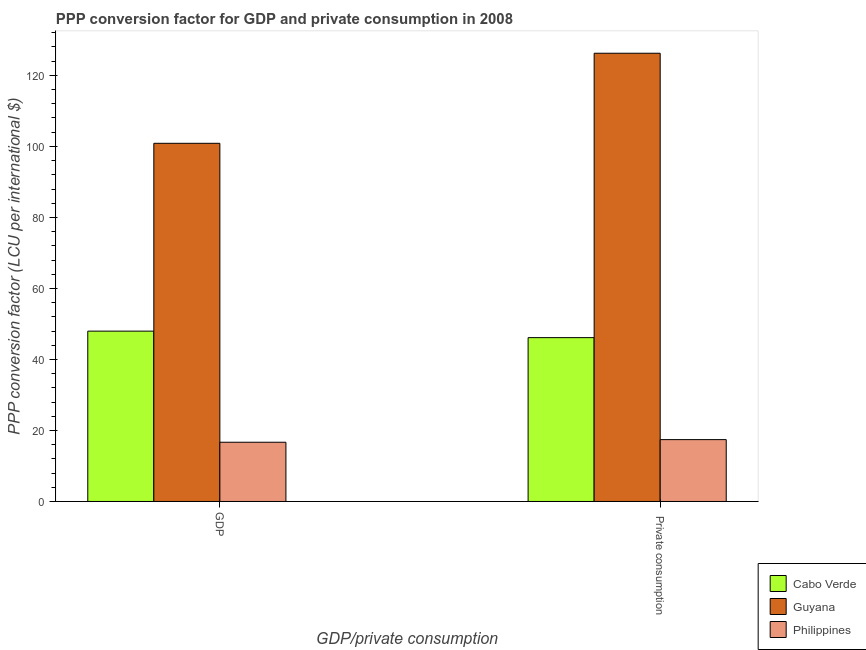How many groups of bars are there?
Offer a very short reply. 2. Are the number of bars on each tick of the X-axis equal?
Your answer should be compact. Yes. How many bars are there on the 1st tick from the right?
Your answer should be compact. 3. What is the label of the 1st group of bars from the left?
Your response must be concise. GDP. What is the ppp conversion factor for gdp in Guyana?
Your response must be concise. 100.87. Across all countries, what is the maximum ppp conversion factor for gdp?
Give a very brief answer. 100.87. Across all countries, what is the minimum ppp conversion factor for private consumption?
Make the answer very short. 17.42. In which country was the ppp conversion factor for private consumption maximum?
Provide a succinct answer. Guyana. What is the total ppp conversion factor for private consumption in the graph?
Your answer should be very brief. 189.8. What is the difference between the ppp conversion factor for gdp in Cabo Verde and that in Guyana?
Ensure brevity in your answer.  -52.9. What is the difference between the ppp conversion factor for gdp in Cabo Verde and the ppp conversion factor for private consumption in Philippines?
Ensure brevity in your answer.  30.55. What is the average ppp conversion factor for private consumption per country?
Give a very brief answer. 63.27. What is the difference between the ppp conversion factor for gdp and ppp conversion factor for private consumption in Guyana?
Provide a succinct answer. -25.36. In how many countries, is the ppp conversion factor for private consumption greater than 24 LCU?
Your response must be concise. 2. What is the ratio of the ppp conversion factor for private consumption in Guyana to that in Cabo Verde?
Offer a terse response. 2.74. Is the ppp conversion factor for gdp in Philippines less than that in Cabo Verde?
Give a very brief answer. Yes. What does the 2nd bar from the left in  Private consumption represents?
Your response must be concise. Guyana. Are all the bars in the graph horizontal?
Your answer should be very brief. No. How many countries are there in the graph?
Provide a succinct answer. 3. What is the difference between two consecutive major ticks on the Y-axis?
Ensure brevity in your answer.  20. Where does the legend appear in the graph?
Give a very brief answer. Bottom right. What is the title of the graph?
Your answer should be compact. PPP conversion factor for GDP and private consumption in 2008. Does "Uganda" appear as one of the legend labels in the graph?
Provide a succinct answer. No. What is the label or title of the X-axis?
Make the answer very short. GDP/private consumption. What is the label or title of the Y-axis?
Ensure brevity in your answer.  PPP conversion factor (LCU per international $). What is the PPP conversion factor (LCU per international $) in Cabo Verde in GDP?
Provide a succinct answer. 47.97. What is the PPP conversion factor (LCU per international $) in Guyana in GDP?
Ensure brevity in your answer.  100.87. What is the PPP conversion factor (LCU per international $) of Philippines in GDP?
Offer a terse response. 16.68. What is the PPP conversion factor (LCU per international $) in Cabo Verde in  Private consumption?
Keep it short and to the point. 46.14. What is the PPP conversion factor (LCU per international $) of Guyana in  Private consumption?
Provide a short and direct response. 126.24. What is the PPP conversion factor (LCU per international $) of Philippines in  Private consumption?
Your response must be concise. 17.42. Across all GDP/private consumption, what is the maximum PPP conversion factor (LCU per international $) of Cabo Verde?
Ensure brevity in your answer.  47.97. Across all GDP/private consumption, what is the maximum PPP conversion factor (LCU per international $) in Guyana?
Make the answer very short. 126.24. Across all GDP/private consumption, what is the maximum PPP conversion factor (LCU per international $) of Philippines?
Provide a succinct answer. 17.42. Across all GDP/private consumption, what is the minimum PPP conversion factor (LCU per international $) in Cabo Verde?
Provide a succinct answer. 46.14. Across all GDP/private consumption, what is the minimum PPP conversion factor (LCU per international $) in Guyana?
Your answer should be very brief. 100.87. Across all GDP/private consumption, what is the minimum PPP conversion factor (LCU per international $) in Philippines?
Ensure brevity in your answer.  16.68. What is the total PPP conversion factor (LCU per international $) of Cabo Verde in the graph?
Provide a short and direct response. 94.12. What is the total PPP conversion factor (LCU per international $) in Guyana in the graph?
Make the answer very short. 227.11. What is the total PPP conversion factor (LCU per international $) in Philippines in the graph?
Provide a short and direct response. 34.1. What is the difference between the PPP conversion factor (LCU per international $) of Cabo Verde in GDP and that in  Private consumption?
Ensure brevity in your answer.  1.83. What is the difference between the PPP conversion factor (LCU per international $) of Guyana in GDP and that in  Private consumption?
Give a very brief answer. -25.36. What is the difference between the PPP conversion factor (LCU per international $) in Philippines in GDP and that in  Private consumption?
Your answer should be compact. -0.74. What is the difference between the PPP conversion factor (LCU per international $) of Cabo Verde in GDP and the PPP conversion factor (LCU per international $) of Guyana in  Private consumption?
Keep it short and to the point. -78.26. What is the difference between the PPP conversion factor (LCU per international $) of Cabo Verde in GDP and the PPP conversion factor (LCU per international $) of Philippines in  Private consumption?
Provide a short and direct response. 30.55. What is the difference between the PPP conversion factor (LCU per international $) in Guyana in GDP and the PPP conversion factor (LCU per international $) in Philippines in  Private consumption?
Your answer should be very brief. 83.45. What is the average PPP conversion factor (LCU per international $) in Cabo Verde per GDP/private consumption?
Ensure brevity in your answer.  47.06. What is the average PPP conversion factor (LCU per international $) of Guyana per GDP/private consumption?
Give a very brief answer. 113.55. What is the average PPP conversion factor (LCU per international $) of Philippines per GDP/private consumption?
Make the answer very short. 17.05. What is the difference between the PPP conversion factor (LCU per international $) of Cabo Verde and PPP conversion factor (LCU per international $) of Guyana in GDP?
Offer a terse response. -52.9. What is the difference between the PPP conversion factor (LCU per international $) in Cabo Verde and PPP conversion factor (LCU per international $) in Philippines in GDP?
Your answer should be very brief. 31.29. What is the difference between the PPP conversion factor (LCU per international $) in Guyana and PPP conversion factor (LCU per international $) in Philippines in GDP?
Provide a succinct answer. 84.19. What is the difference between the PPP conversion factor (LCU per international $) of Cabo Verde and PPP conversion factor (LCU per international $) of Guyana in  Private consumption?
Give a very brief answer. -80.09. What is the difference between the PPP conversion factor (LCU per international $) in Cabo Verde and PPP conversion factor (LCU per international $) in Philippines in  Private consumption?
Offer a terse response. 28.72. What is the difference between the PPP conversion factor (LCU per international $) of Guyana and PPP conversion factor (LCU per international $) of Philippines in  Private consumption?
Offer a terse response. 108.82. What is the ratio of the PPP conversion factor (LCU per international $) in Cabo Verde in GDP to that in  Private consumption?
Ensure brevity in your answer.  1.04. What is the ratio of the PPP conversion factor (LCU per international $) in Guyana in GDP to that in  Private consumption?
Offer a terse response. 0.8. What is the ratio of the PPP conversion factor (LCU per international $) in Philippines in GDP to that in  Private consumption?
Your answer should be very brief. 0.96. What is the difference between the highest and the second highest PPP conversion factor (LCU per international $) in Cabo Verde?
Give a very brief answer. 1.83. What is the difference between the highest and the second highest PPP conversion factor (LCU per international $) of Guyana?
Your response must be concise. 25.36. What is the difference between the highest and the second highest PPP conversion factor (LCU per international $) in Philippines?
Your response must be concise. 0.74. What is the difference between the highest and the lowest PPP conversion factor (LCU per international $) in Cabo Verde?
Your answer should be compact. 1.83. What is the difference between the highest and the lowest PPP conversion factor (LCU per international $) in Guyana?
Your response must be concise. 25.36. What is the difference between the highest and the lowest PPP conversion factor (LCU per international $) of Philippines?
Your answer should be compact. 0.74. 